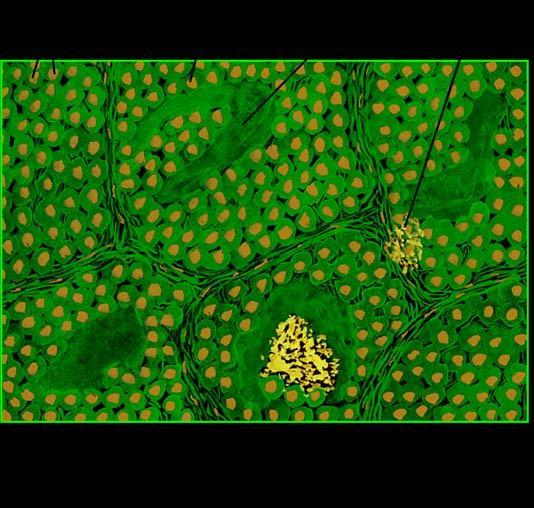what shows congophilia which depicts apple-green birefringence under polarising microscopy?
Answer the question using a single word or phrase. Amyloid 